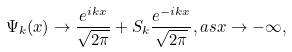Convert formula to latex. <formula><loc_0><loc_0><loc_500><loc_500>\Psi _ { k } ( x ) \rightarrow \frac { e ^ { i k x } } { \sqrt { 2 \pi } } + S _ { k } \frac { e ^ { - i k x } } { \sqrt { 2 \pi } } , a s x \rightarrow - \infty ,</formula> 